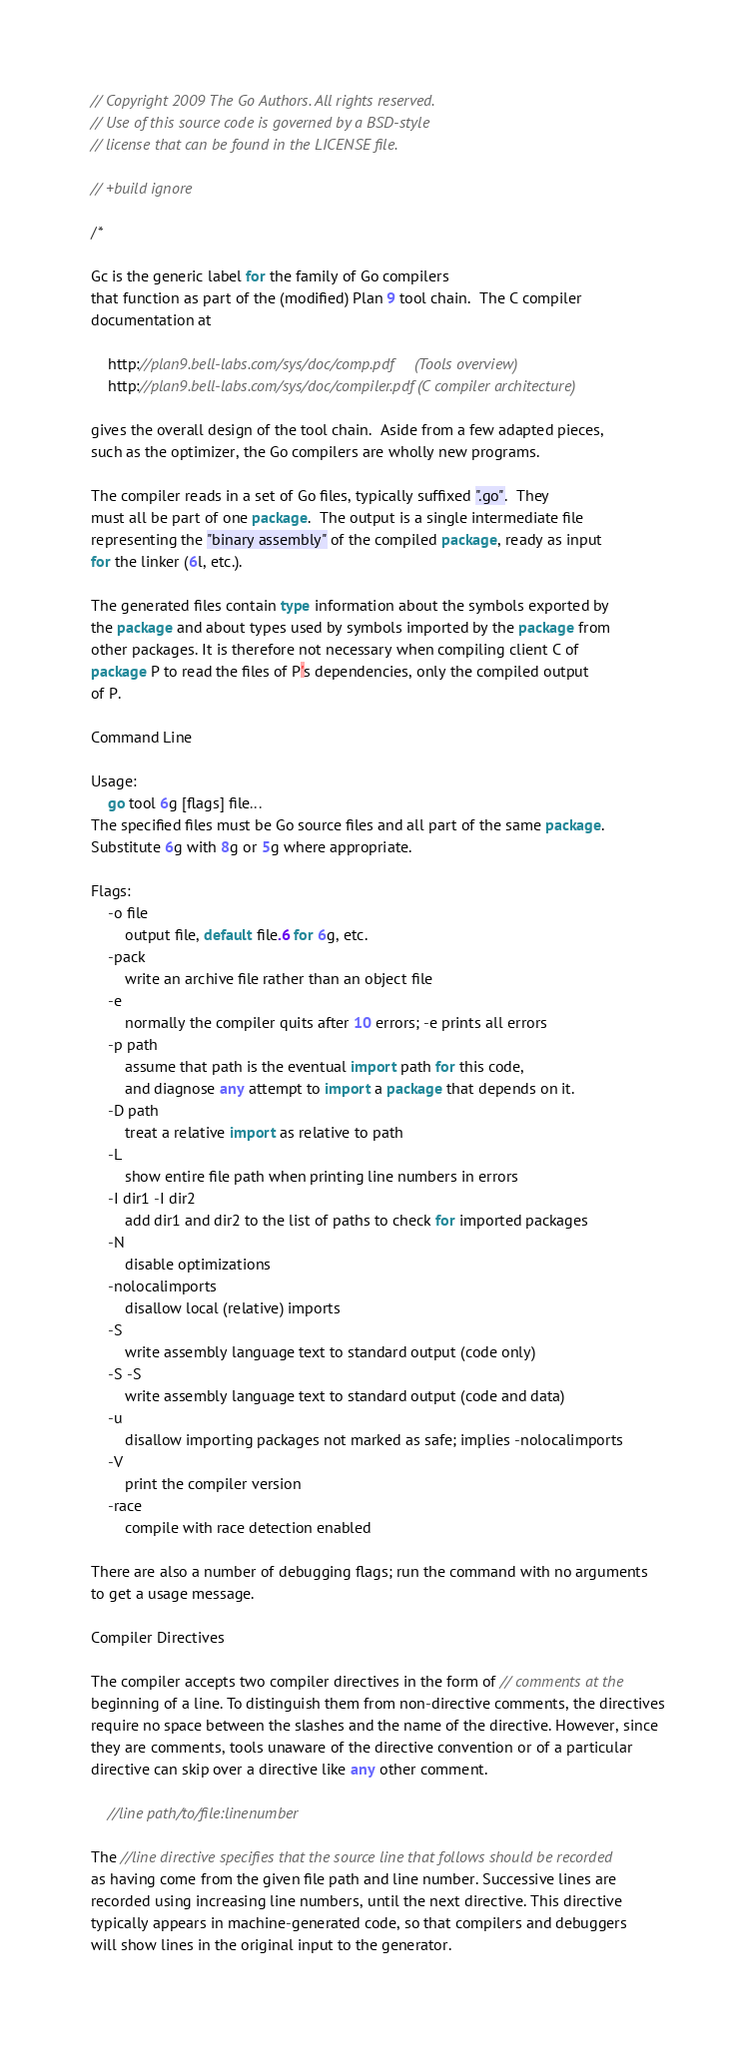Convert code to text. <code><loc_0><loc_0><loc_500><loc_500><_Go_>// Copyright 2009 The Go Authors. All rights reserved.
// Use of this source code is governed by a BSD-style
// license that can be found in the LICENSE file.

// +build ignore

/*

Gc is the generic label for the family of Go compilers
that function as part of the (modified) Plan 9 tool chain.  The C compiler
documentation at

	http://plan9.bell-labs.com/sys/doc/comp.pdf     (Tools overview)
	http://plan9.bell-labs.com/sys/doc/compiler.pdf (C compiler architecture)

gives the overall design of the tool chain.  Aside from a few adapted pieces,
such as the optimizer, the Go compilers are wholly new programs.

The compiler reads in a set of Go files, typically suffixed ".go".  They
must all be part of one package.  The output is a single intermediate file
representing the "binary assembly" of the compiled package, ready as input
for the linker (6l, etc.).

The generated files contain type information about the symbols exported by
the package and about types used by symbols imported by the package from
other packages. It is therefore not necessary when compiling client C of
package P to read the files of P's dependencies, only the compiled output
of P.

Command Line

Usage:
	go tool 6g [flags] file...
The specified files must be Go source files and all part of the same package.
Substitute 6g with 8g or 5g where appropriate.

Flags:
	-o file
		output file, default file.6 for 6g, etc.
	-pack
		write an archive file rather than an object file
	-e
		normally the compiler quits after 10 errors; -e prints all errors
	-p path
		assume that path is the eventual import path for this code,
		and diagnose any attempt to import a package that depends on it.
	-D path
		treat a relative import as relative to path
	-L
		show entire file path when printing line numbers in errors
	-I dir1 -I dir2
		add dir1 and dir2 to the list of paths to check for imported packages
	-N
		disable optimizations
	-nolocalimports
		disallow local (relative) imports
	-S
		write assembly language text to standard output (code only)
	-S -S
		write assembly language text to standard output (code and data)
	-u
		disallow importing packages not marked as safe; implies -nolocalimports
	-V
		print the compiler version
	-race
		compile with race detection enabled

There are also a number of debugging flags; run the command with no arguments
to get a usage message.

Compiler Directives

The compiler accepts two compiler directives in the form of // comments at the
beginning of a line. To distinguish them from non-directive comments, the directives
require no space between the slashes and the name of the directive. However, since
they are comments, tools unaware of the directive convention or of a particular
directive can skip over a directive like any other comment.

    //line path/to/file:linenumber

The //line directive specifies that the source line that follows should be recorded
as having come from the given file path and line number. Successive lines are
recorded using increasing line numbers, until the next directive. This directive
typically appears in machine-generated code, so that compilers and debuggers
will show lines in the original input to the generator.
</code> 